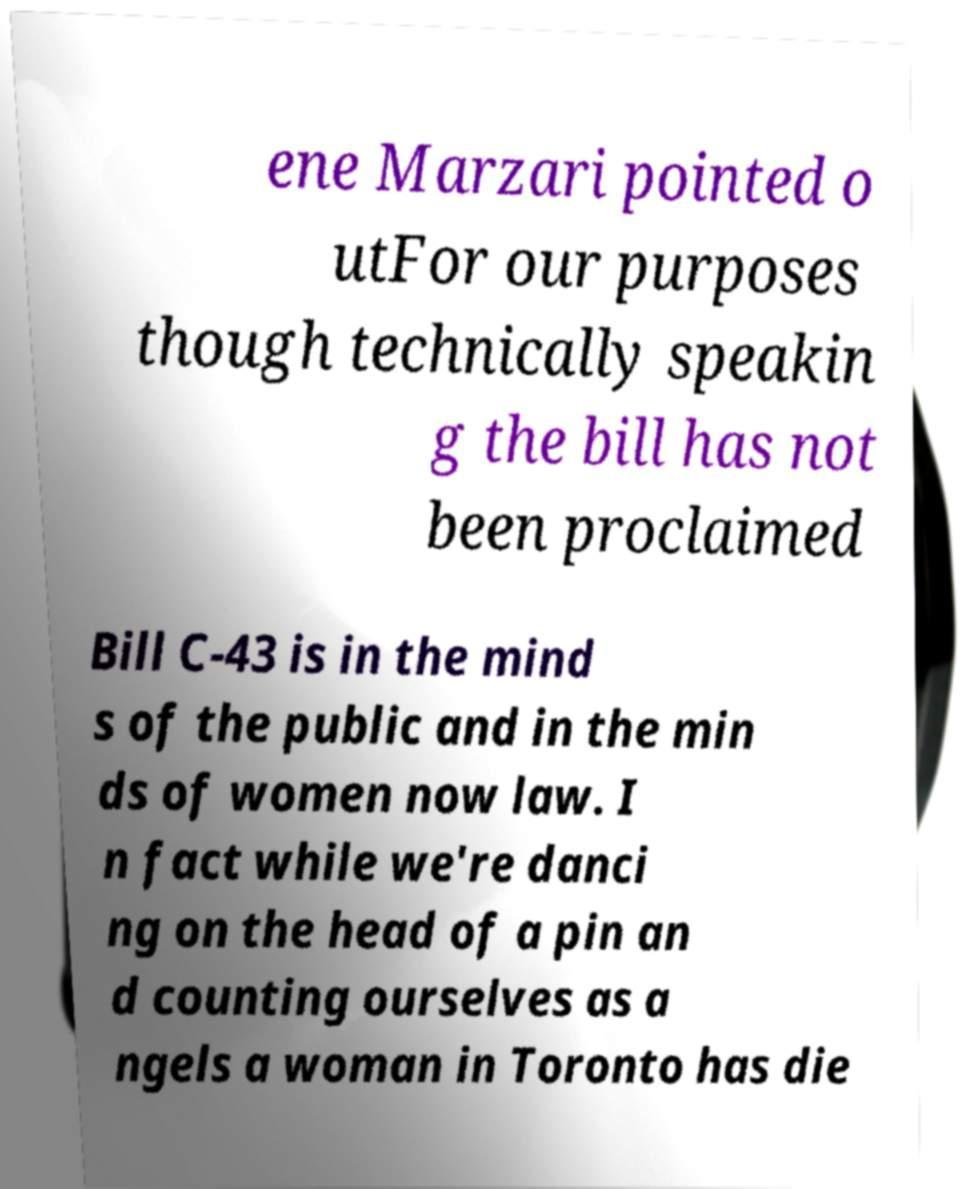There's text embedded in this image that I need extracted. Can you transcribe it verbatim? ene Marzari pointed o utFor our purposes though technically speakin g the bill has not been proclaimed Bill C-43 is in the mind s of the public and in the min ds of women now law. I n fact while we're danci ng on the head of a pin an d counting ourselves as a ngels a woman in Toronto has die 